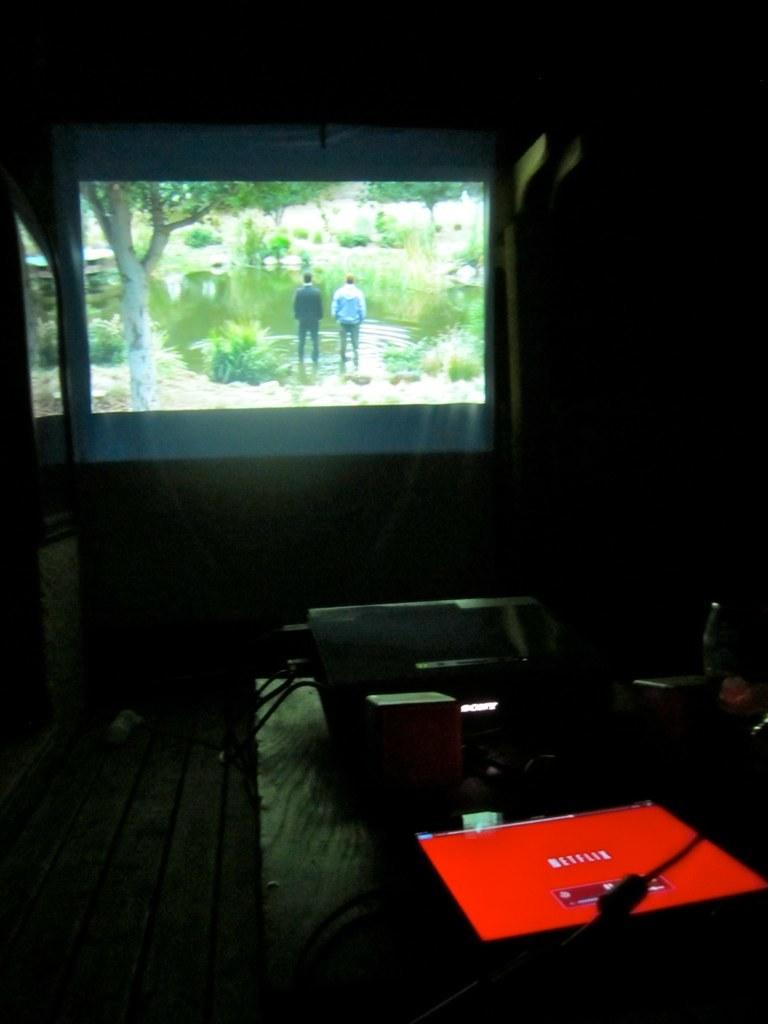What is the main object on the table in the image? There is a projector on the table in the image. What other electronic device can be seen on the table? There is another electronic device on the table. How is the electronic device connected to other devices? The electronic device has cables attached to it. What is the purpose of the screen in front of the projector? The screen is in front of the projector to display the projected image. How does the ornament on the table contribute to the destruction of the electronic devices? There is no ornament present on the table in the image, and therefore it cannot contribute to the destruction of the electronic devices. 